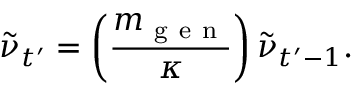Convert formula to latex. <formula><loc_0><loc_0><loc_500><loc_500>\tilde { \nu } _ { t ^ { \prime } } = \left ( \frac { m _ { g e n } } { \kappa } \right ) \tilde { \nu } _ { t ^ { \prime } - 1 } .</formula> 